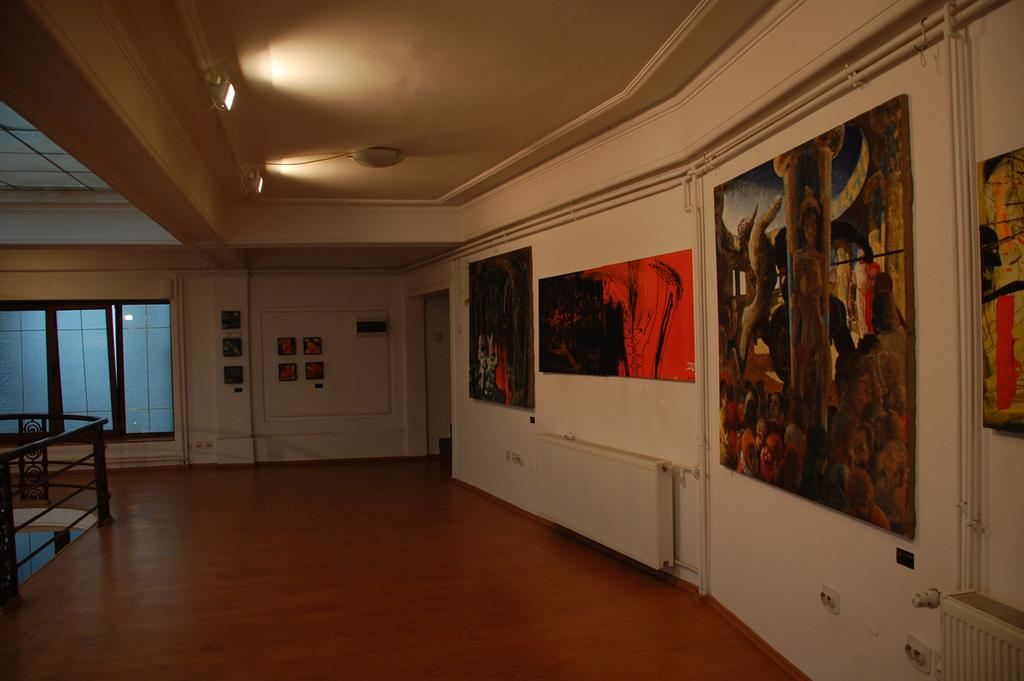Where was the image taken? The image was taken inside a room. What can be seen at the top of the room? There are lights at the top of the room. What decorations are on the walls in the room? There are paintings on the walls. What can be seen on the left side of the room? There are windows on the left side of the room. What type of brass instrument is being played in the image? There is no brass instrument or any indication of music being played in the image. 